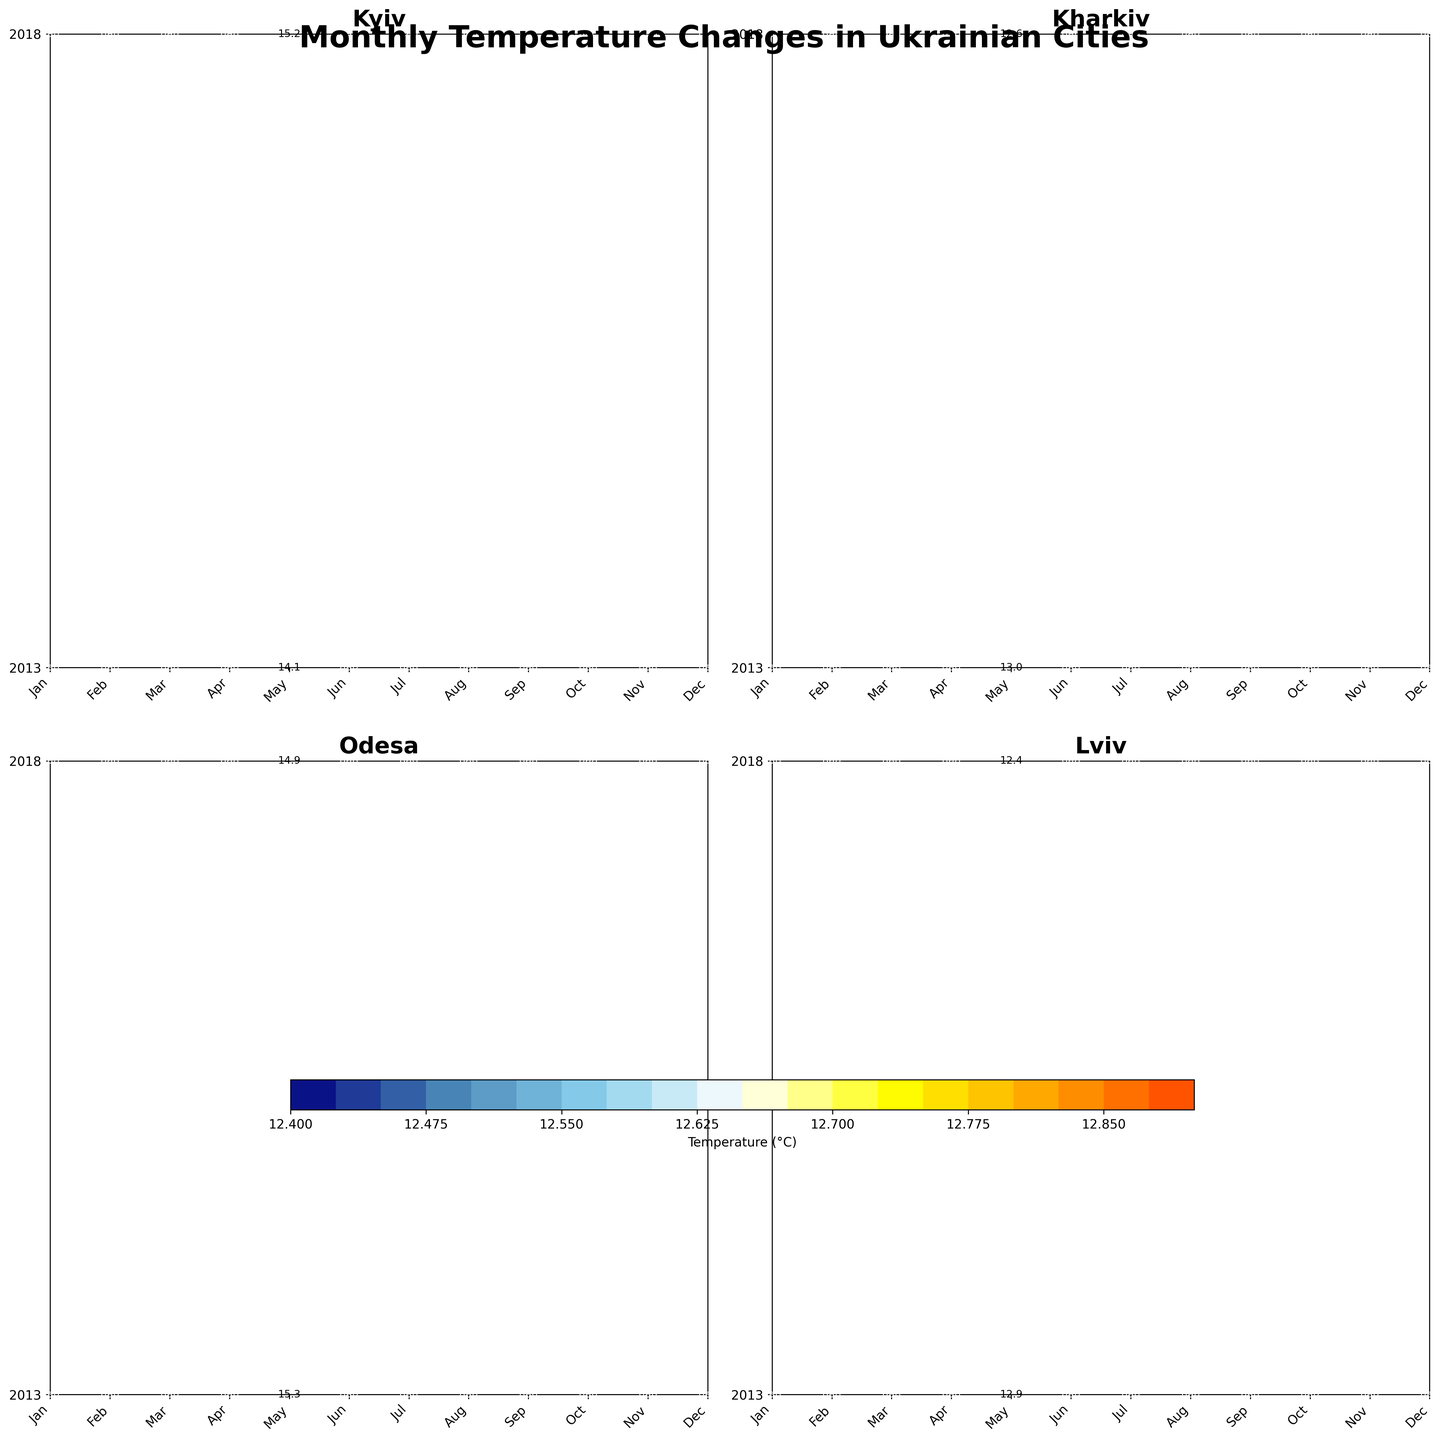What is the title of the figure? The title is generally found at the top of the figure. In this case, it appears above the city-specific subplots.
Answer: Monthly Temperature Changes in Ukrainian Cities Which city experienced the highest average temperature in July 2018? To determine the highest average temperature, look at the July 2018 data across all cities' subplots. Find the value representing the highest temperature and the corresponding city label.
Answer: Odesa In which month did Kyiv have the lowest temperature in 2018? Check each month's temperature value for Kyiv in 2018 and identify the month with the lowest value.
Answer: February How did Odesa's average temperature change from January to December in 2013? Scan through Odesa's subplot for 2013 and read the temperature labels from January to December.
Answer: It started at 0.2°C in January and ended at 1.2°C in December Which city had the most consistent temperatures throughout the decade? Look at the contour lines for each city and identify the city with the least variation in temperature across months and years. Consistent temperatures usually result in more uniform contour lines.
Answer: Odesa What was the temperature difference for Kharkiv between January 2013 and January 2018? Locate the temperature for January 2013 and January 2018 in Kharkiv's subplot and calculate the difference by subtracting the two values.
Answer: -0.9°C ( -6.2 - (-5.3)) Which city showed the most significant temperature increase in March from 2013 to 2018? Compare the temperature increase in March between 2013 and 2018 for each city by calculating the difference for all cities and identifying the highest increase.
Answer: Kyiv Did Lviv experience any month with average temperature above 20°C from 2013 to 2018? Inspect all the monthly temperatures for Lviv between 2013 and 2018 and check if any of them indicate a temperature above 20°C.
Answer: No Which year had the warmest October in Kharkiv? Compare the October temperatures for Kharkiv between the years provided and find the highest value.
Answer: 2018 How do the temperature patterns between Lviv and Kharkiv compare during the winter months of January and February? Look at the January and February temperature values for both Lviv and Kharkiv and compare. Note if any city's winter month is consistently warmer or colder.
Answer: Lviv is generally warmer than Kharkiv in January and February 